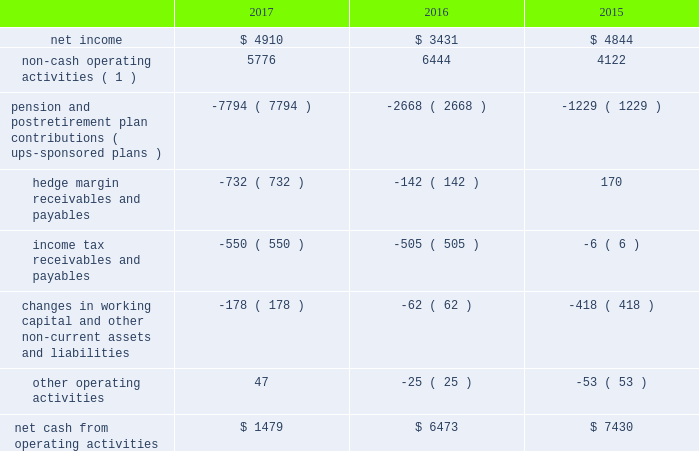United parcel service , inc .
And subsidiaries management's discussion and analysis of financial condition and results of operations liquidity and capital resources as of december 31 , 2017 , we had $ 4.069 billion in cash , cash equivalents and marketable securities .
We believe that our current cash position , access to the long-term debt capital markets and cash flow generated from operations should be adequate not only for operating requirements but also to enable us to complete our capital expenditure programs and to fund dividend payments , share repurchases and long-term debt payments through the next several years .
In addition , we have funds available from our commercial paper program and the ability to obtain alternative sources of financing .
We regularly evaluate opportunities to optimize our capital structure , including through issuances of debt to refinance existing debt and to fund ongoing cash needs .
Cash flows from operating activities the following is a summary of the significant sources ( uses ) of cash from operating activities ( amounts in millions ) : .
( 1 ) represents depreciation and amortization , gains and losses on derivative transactions and foreign exchange , deferred income taxes , provisions for uncollectible accounts , pension and postretirement benefit expense , stock compensation expense and other non-cash items .
Cash from operating activities remained strong throughout 2015 to 2017 .
Most of the variability in operating cash flows during the 2015 to 2017 time period relates to the funding of our company-sponsored pension and postretirement benefit plans ( and related cash tax deductions ) .
Except for discretionary or accelerated fundings of our plans , contributions to our company- sponsored pension plans have largely varied based on whether any minimum funding requirements are present for individual pension plans .
2022 we made discretionary contributions to our three primary company-sponsored u.s .
Pension plans totaling $ 7.291 , $ 2.461 and $ 1.030 billion in 2017 , 2016 and 2015 , respectively .
2022 the remaining contributions from 2015 to 2017 were largely due to contributions to our international pension plans and u.s .
Postretirement medical benefit plans .
Apart from the transactions described above , operating cash flow was impacted by changes in our working capital position , payments for income taxes and changes in hedge margin payables and receivables .
Cash payments for income taxes were $ 1.559 , $ 2.064 and $ 1.913 billion for 2017 , 2016 and 2015 , respectively , and were primarily impacted by the timing of current tax deductions .
The net hedge margin collateral ( paid ) /received from derivative counterparties was $ ( 732 ) , $ ( 142 ) and $ 170 million during 2017 , 2016 and 2015 , respectively , due to settlements and changes in the fair value of the derivative contracts used in our currency and interest rate hedging programs .
As of december 31 , 2017 , the total of our worldwide holdings of cash , cash equivalents and marketable securities were $ 4.069 billion , of which approximately $ 1.800 billion was held by foreign subsidiaries .
The amount of cash , cash equivalents and marketable securities held by our u.s .
And foreign subsidiaries fluctuates throughout the year due to a variety of factors , including the timing of cash receipts and disbursements in the normal course of business .
Cash provided by operating activities in the u.s .
Continues to be our primary source of funds to finance domestic operating needs , capital expenditures , share repurchases and dividend payments to shareowners .
As a result of the tax act , all cash , cash equivalents and marketable securities held by foreign subsidiaries are generally available for distribution to the u.s .
Without any u.s .
Federal income taxes .
Any such distributions may be subject to foreign withholding and u.s .
State taxes .
When amounts earned by foreign subsidiaries are expected to be indefinitely reinvested , no accrual for taxes is provided. .
What was the difference in millions of pension and postretirement plan contributions ( ups-sponsored plans ) from 2015 to 2016? 
Computations: (2668 - 1229)
Answer: 1439.0. 